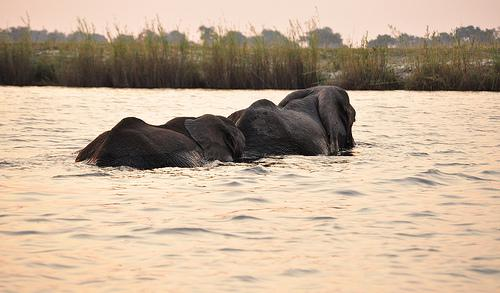Question: what animals are in the picture?
Choices:
A. Dogs.
B. Elephants.
C. Cats.
D. Birds.
Answer with the letter. Answer: B Question: what are the elephants doing?
Choices:
A. Eating.
B. Carrying people.
C. Bathing.
D. Performing at a circus.
Answer with the letter. Answer: C Question: where are the elephants?
Choices:
A. On the balls.
B. In the river.
C. In the zoo.
D. On the plains.
Answer with the letter. Answer: B Question: what part of elephants is visible?
Choices:
A. Front.
B. Top.
C. Bottom.
D. Back.
Answer with the letter. Answer: D Question: how many elephants are in the picture?
Choices:
A. Three.
B. One.
C. Two.
D. Four.
Answer with the letter. Answer: C Question: what is on the river bank?
Choices:
A. Sand.
B. Gravel.
C. Grass.
D. Dirt.
Answer with the letter. Answer: C 